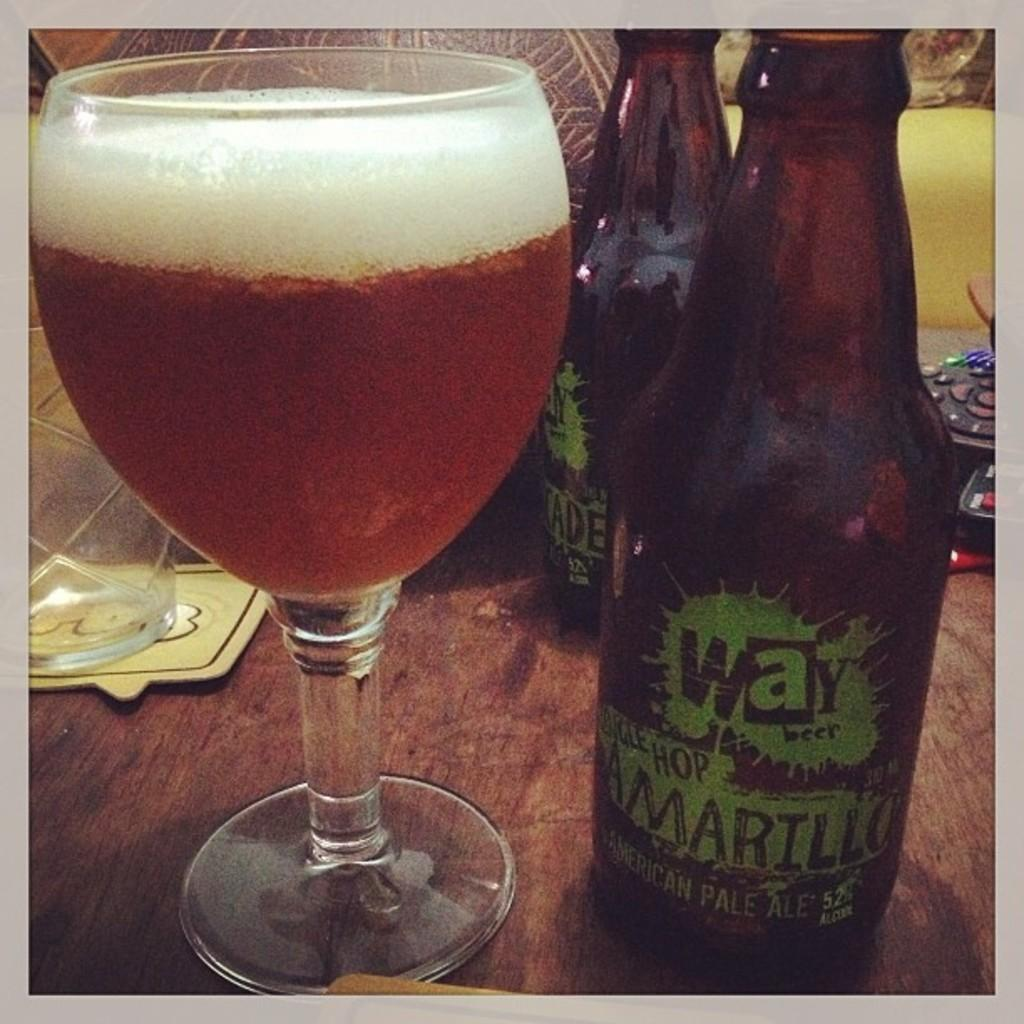<image>
Render a clear and concise summary of the photo. the word way is on a beer bottle 